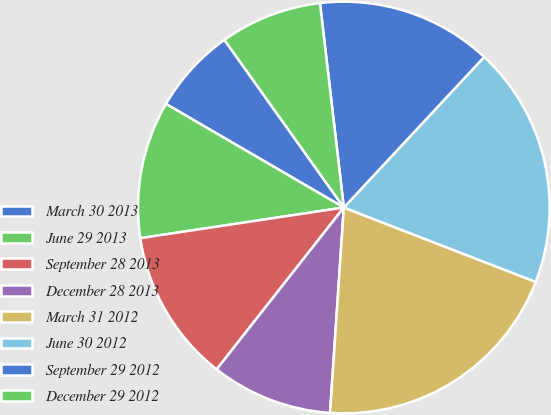Convert chart to OTSL. <chart><loc_0><loc_0><loc_500><loc_500><pie_chart><fcel>March 30 2013<fcel>June 29 2013<fcel>September 28 2013<fcel>December 28 2013<fcel>March 31 2012<fcel>June 30 2012<fcel>September 29 2012<fcel>December 29 2012<nl><fcel>6.76%<fcel>10.77%<fcel>12.02%<fcel>9.53%<fcel>20.18%<fcel>18.94%<fcel>13.79%<fcel>8.0%<nl></chart> 